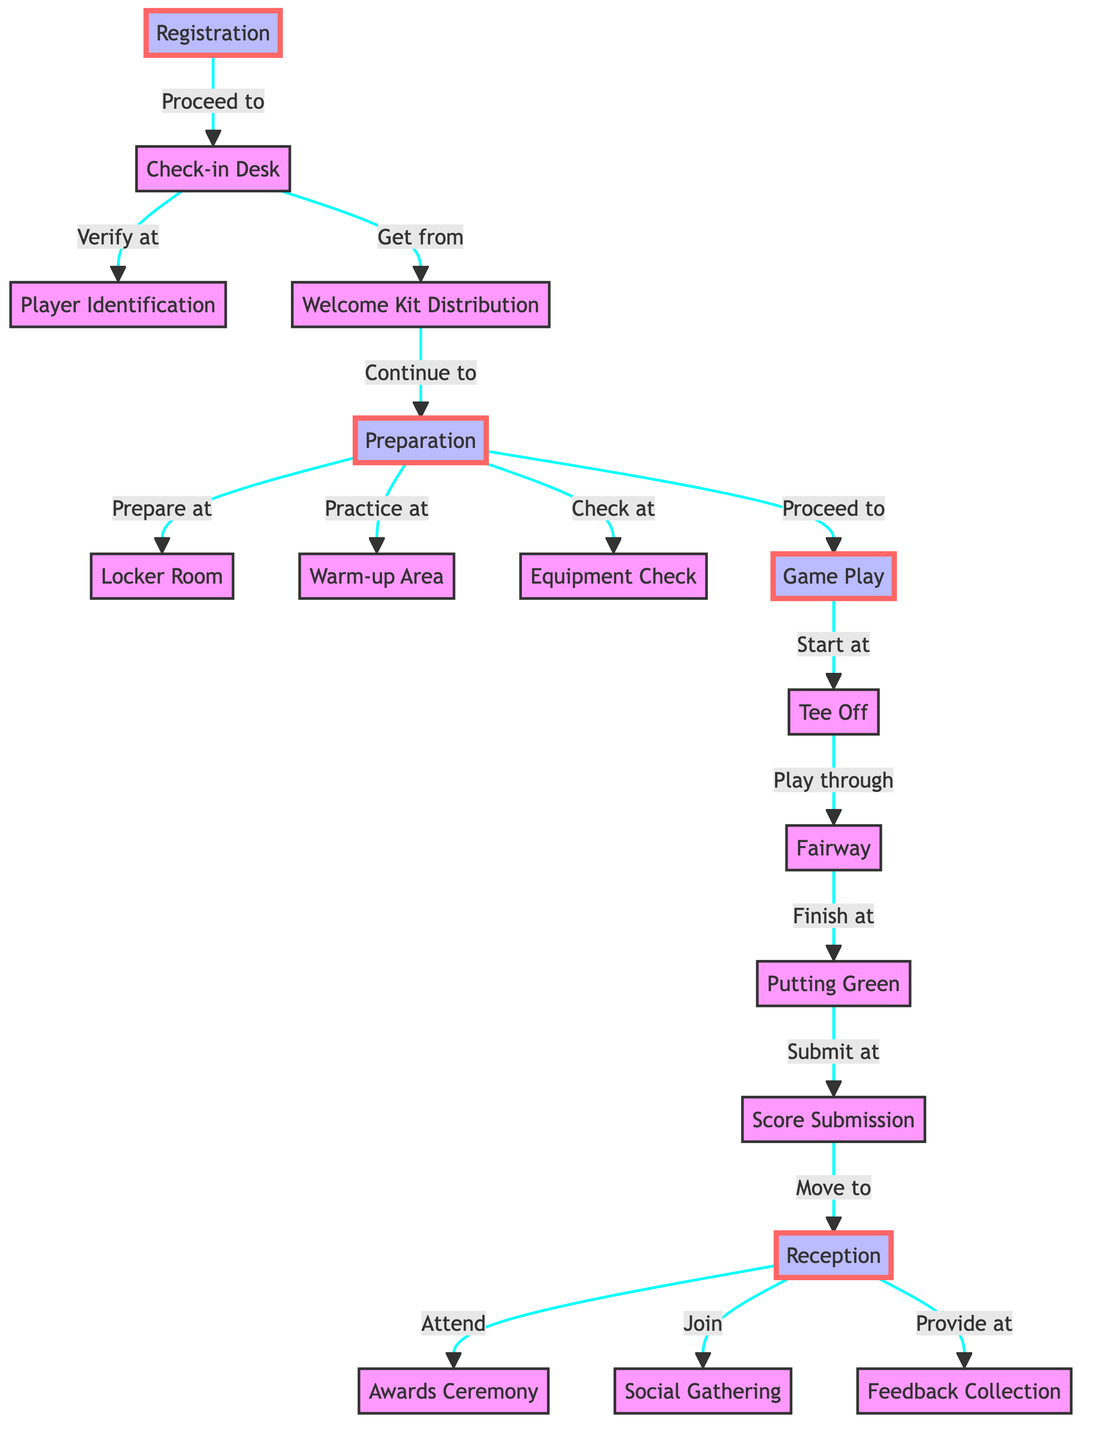What are the first two steps after registration? The diagram shows that after registration, the first step is to proceed to the check-in desk and the second step at the check-in desk involves verifying at player identification.
Answer: Proceed to check-in desk, verify at player identification How many nodes represent the game play phase? The diagram identifies three nodes that represent the game play phase: tee off, fairway, and putting green. Counting those nodes gives a total of three.
Answer: Three What does the player receive at the check-in desk? According to the diagram, from the check-in desk, the flow indicates players get a welcome kit. Thus, the item they receive is the welcome kit.
Answer: Welcome kit Which nodes do players move to after score submission? After score submission, players move to reception. This is the only immediate next step indicated in the diagram.
Answer: Reception What does the player do at the warm-up area? In the diagram, players practice at the warm-up area after moving there from the preparation phase. The specific action mentioned is practicing.
Answer: Practice How many edges are connected to the reception node? The reception node has three edges connected to it, representing the transition to the awards ceremony, joining the social gathering, and providing feedback. Thus, there are three edges.
Answer: Three What are the last two activities players participate in after leaving reception? Following reception, players first attend the awards ceremony and then join the social gathering. Therefore, these are the last two activities listed in that order.
Answer: Attend awards ceremony, join social gathering What is the purpose of the equipment check node? The equipment check node is meant for players to check their equipment during the preparation phase. This action can be highlighted as verifying their readiness before the game starts.
Answer: Check equipment Which phase precedes the game play phase according to the diagram? The preparation phase directly precedes the game play phase, as indicated by the flow that transitions from preparation to game play in the diagram.
Answer: Preparation 